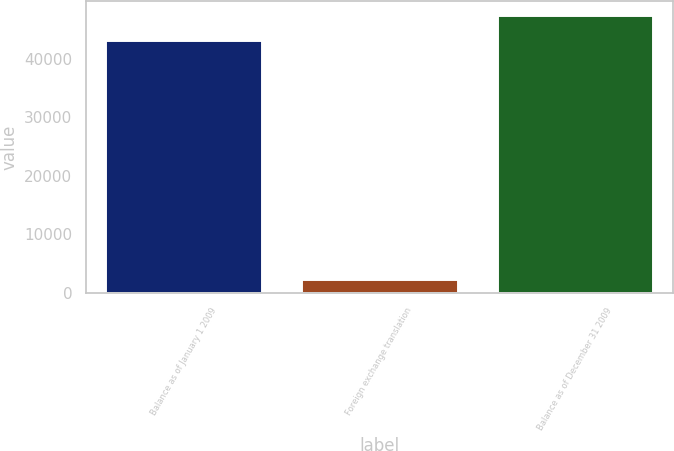Convert chart. <chart><loc_0><loc_0><loc_500><loc_500><bar_chart><fcel>Balance as of January 1 2009<fcel>Foreign exchange translation<fcel>Balance as of December 31 2009<nl><fcel>43142<fcel>2288<fcel>47456.2<nl></chart> 